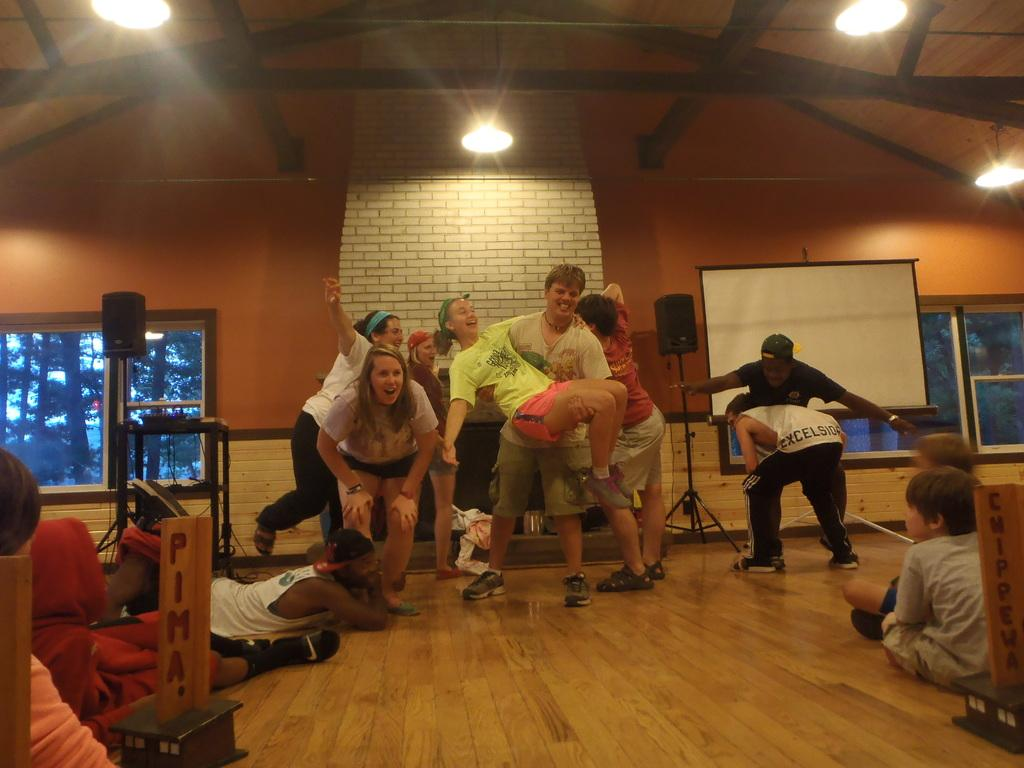<image>
Write a terse but informative summary of the picture. The wooden sign to the left says Pima. 